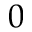<formula> <loc_0><loc_0><loc_500><loc_500>0</formula> 